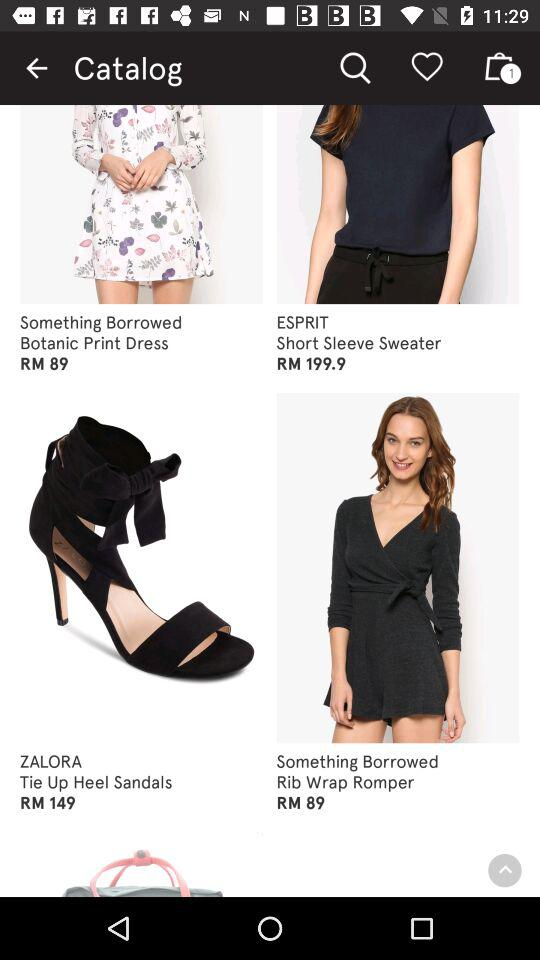What is the price of ZALORA Tie Up Heel Sandals? The price of ZALORA Tie Up Heel Sandals is RM 149. 